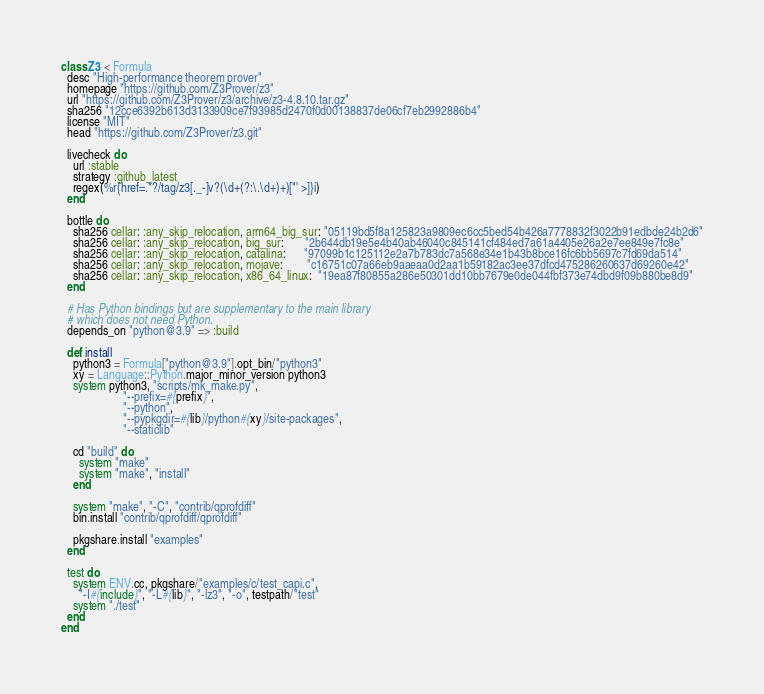Convert code to text. <code><loc_0><loc_0><loc_500><loc_500><_Ruby_>class Z3 < Formula
  desc "High-performance theorem prover"
  homepage "https://github.com/Z3Prover/z3"
  url "https://github.com/Z3Prover/z3/archive/z3-4.8.10.tar.gz"
  sha256 "12cce6392b613d3133909ce7f93985d2470f0d00138837de06cf7eb2992886b4"
  license "MIT"
  head "https://github.com/Z3Prover/z3.git"

  livecheck do
    url :stable
    strategy :github_latest
    regex(%r{href=.*?/tag/z3[._-]v?(\d+(?:\.\d+)+)["' >]}i)
  end

  bottle do
    sha256 cellar: :any_skip_relocation, arm64_big_sur: "05119bd5f8a125823a9809ec6cc5bed54b426a7778832f3022b91edbde24b2d6"
    sha256 cellar: :any_skip_relocation, big_sur:       "2b644db19e5e4b40ab46040c845141cf484ed7a61a4405e26a2e7ee849e7fc8e"
    sha256 cellar: :any_skip_relocation, catalina:      "97099b1c125112e2a7b783dc7a568e34e1b43b8bce16fc6bb5697c7fd69da514"
    sha256 cellar: :any_skip_relocation, mojave:        "c16751c07a66eb9aaeaa0d2aa1b59182ac3ee37dfcd475286260637d69260e42"
    sha256 cellar: :any_skip_relocation, x86_64_linux:  "19ea87f80855a286e50301dd10bb7679e0de044fbf373e74dbd9f09b880be8d9"
  end

  # Has Python bindings but are supplementary to the main library
  # which does not need Python.
  depends_on "python@3.9" => :build

  def install
    python3 = Formula["python@3.9"].opt_bin/"python3"
    xy = Language::Python.major_minor_version python3
    system python3, "scripts/mk_make.py",
                     "--prefix=#{prefix}",
                     "--python",
                     "--pypkgdir=#{lib}/python#{xy}/site-packages",
                     "--staticlib"

    cd "build" do
      system "make"
      system "make", "install"
    end

    system "make", "-C", "contrib/qprofdiff"
    bin.install "contrib/qprofdiff/qprofdiff"

    pkgshare.install "examples"
  end

  test do
    system ENV.cc, pkgshare/"examples/c/test_capi.c",
      "-I#{include}", "-L#{lib}", "-lz3", "-o", testpath/"test"
    system "./test"
  end
end
</code> 